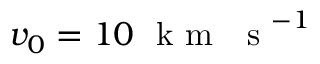<formula> <loc_0><loc_0><loc_500><loc_500>v _ { 0 } = 1 0 k m s ^ { - 1 }</formula> 